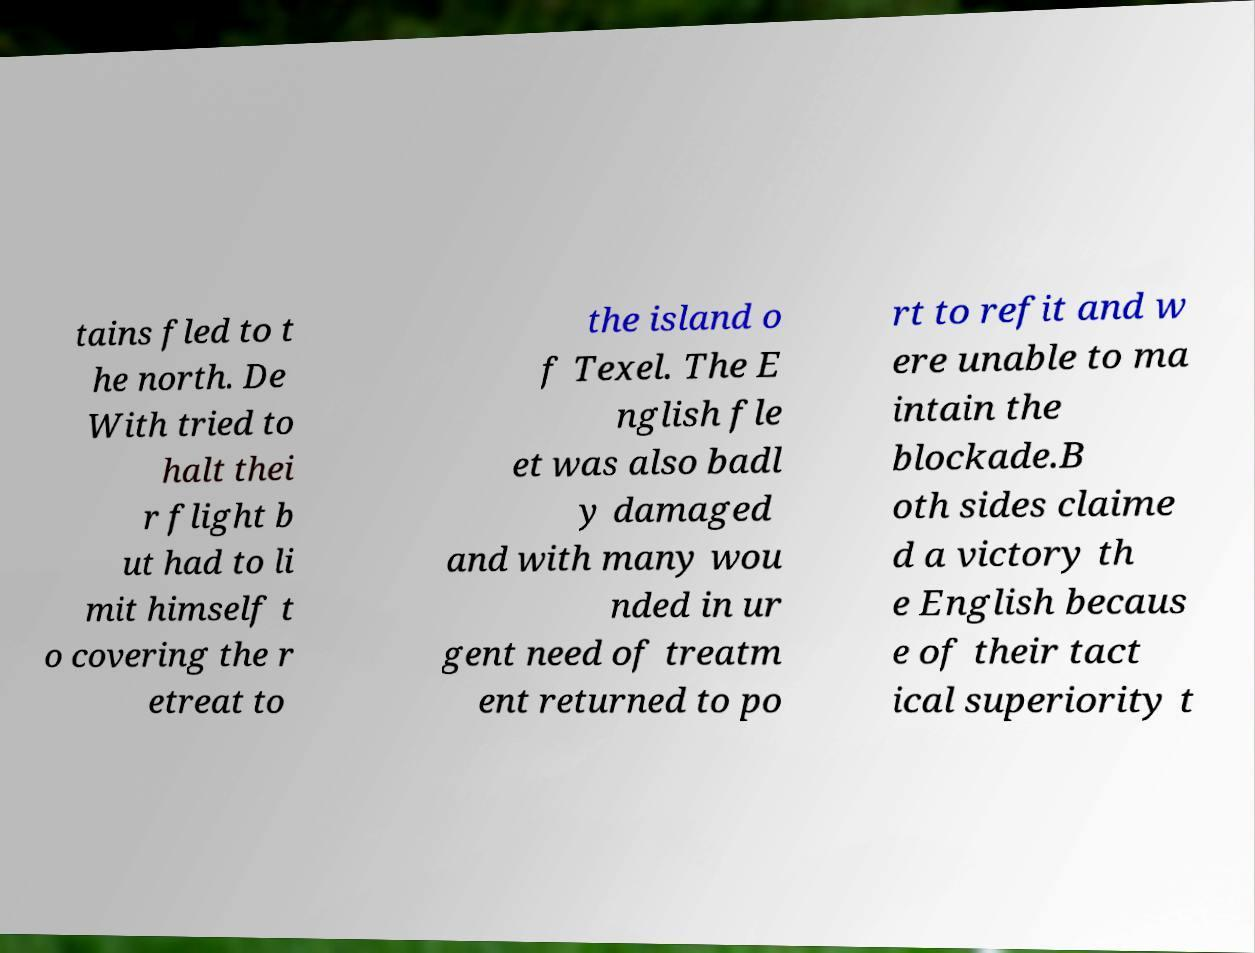What messages or text are displayed in this image? I need them in a readable, typed format. tains fled to t he north. De With tried to halt thei r flight b ut had to li mit himself t o covering the r etreat to the island o f Texel. The E nglish fle et was also badl y damaged and with many wou nded in ur gent need of treatm ent returned to po rt to refit and w ere unable to ma intain the blockade.B oth sides claime d a victory th e English becaus e of their tact ical superiority t 